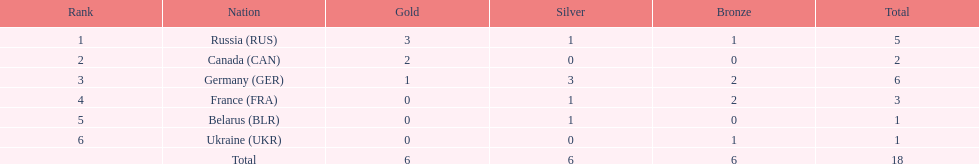Which country won more total medals than tue french, but less than the germans in the 1994 winter olympic biathlon? Russia. 